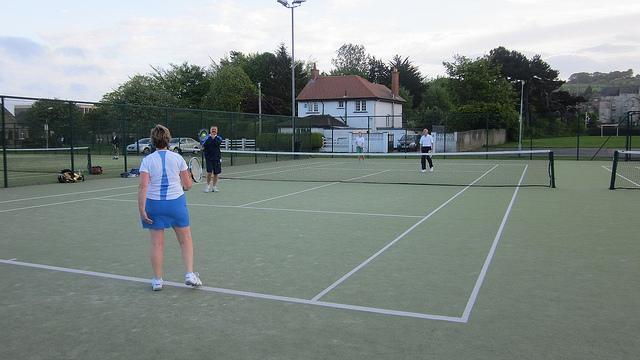Where are her shoes?
Answer briefly. Feet. Is it good weather for a day of tennis?
Short answer required. Yes. What color is the building?
Quick response, please. White. What is the weather like?
Be succinct. Cloudy. 